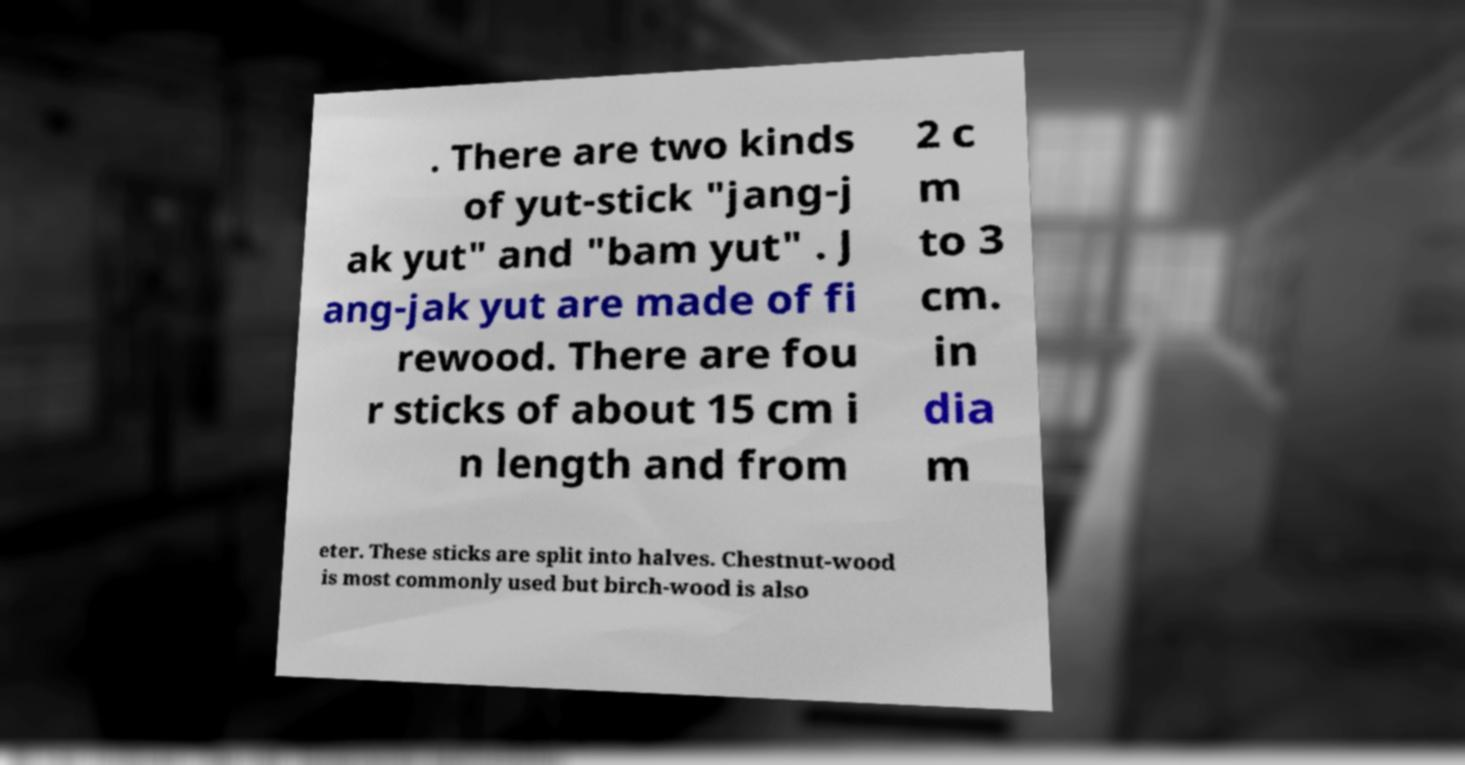Can you accurately transcribe the text from the provided image for me? . There are two kinds of yut-stick "jang-j ak yut" and "bam yut" . J ang-jak yut are made of fi rewood. There are fou r sticks of about 15 cm i n length and from 2 c m to 3 cm. in dia m eter. These sticks are split into halves. Chestnut-wood is most commonly used but birch-wood is also 